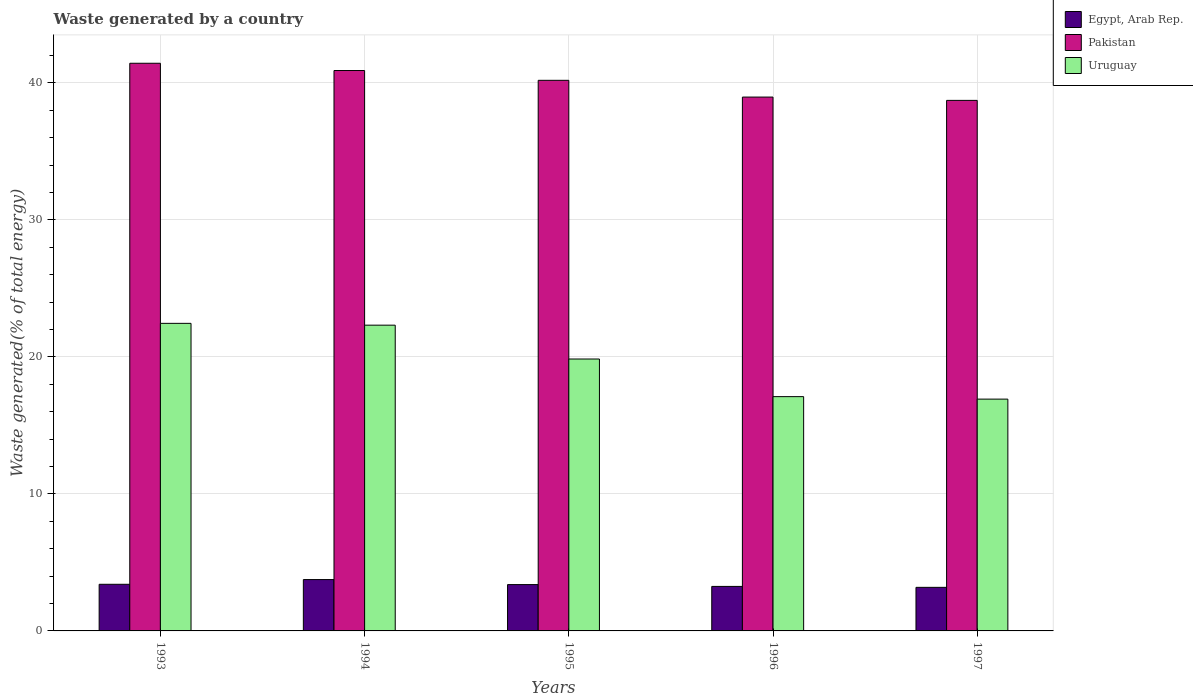Are the number of bars on each tick of the X-axis equal?
Provide a short and direct response. Yes. How many bars are there on the 3rd tick from the right?
Provide a short and direct response. 3. What is the label of the 5th group of bars from the left?
Keep it short and to the point. 1997. What is the total waste generated in Egypt, Arab Rep. in 1994?
Make the answer very short. 3.75. Across all years, what is the maximum total waste generated in Egypt, Arab Rep.?
Offer a terse response. 3.75. Across all years, what is the minimum total waste generated in Pakistan?
Offer a very short reply. 38.72. In which year was the total waste generated in Uruguay maximum?
Your answer should be very brief. 1993. In which year was the total waste generated in Pakistan minimum?
Offer a very short reply. 1997. What is the total total waste generated in Pakistan in the graph?
Offer a very short reply. 200.21. What is the difference between the total waste generated in Uruguay in 1994 and that in 1997?
Offer a terse response. 5.4. What is the difference between the total waste generated in Uruguay in 1993 and the total waste generated in Pakistan in 1994?
Offer a very short reply. -18.45. What is the average total waste generated in Egypt, Arab Rep. per year?
Keep it short and to the point. 3.39. In the year 1996, what is the difference between the total waste generated in Egypt, Arab Rep. and total waste generated in Uruguay?
Ensure brevity in your answer.  -13.85. In how many years, is the total waste generated in Uruguay greater than 36 %?
Make the answer very short. 0. What is the ratio of the total waste generated in Egypt, Arab Rep. in 1995 to that in 1997?
Your response must be concise. 1.06. What is the difference between the highest and the second highest total waste generated in Pakistan?
Make the answer very short. 0.53. What is the difference between the highest and the lowest total waste generated in Pakistan?
Your answer should be compact. 2.71. In how many years, is the total waste generated in Uruguay greater than the average total waste generated in Uruguay taken over all years?
Offer a terse response. 3. Is the sum of the total waste generated in Pakistan in 1995 and 1996 greater than the maximum total waste generated in Egypt, Arab Rep. across all years?
Ensure brevity in your answer.  Yes. What does the 3rd bar from the left in 1996 represents?
Your answer should be compact. Uruguay. What does the 1st bar from the right in 1996 represents?
Provide a short and direct response. Uruguay. Is it the case that in every year, the sum of the total waste generated in Egypt, Arab Rep. and total waste generated in Pakistan is greater than the total waste generated in Uruguay?
Provide a short and direct response. Yes. How many bars are there?
Offer a very short reply. 15. Are all the bars in the graph horizontal?
Provide a succinct answer. No. Are the values on the major ticks of Y-axis written in scientific E-notation?
Provide a short and direct response. No. Does the graph contain grids?
Offer a very short reply. Yes. Where does the legend appear in the graph?
Your answer should be compact. Top right. How many legend labels are there?
Offer a terse response. 3. How are the legend labels stacked?
Give a very brief answer. Vertical. What is the title of the graph?
Give a very brief answer. Waste generated by a country. Does "Mozambique" appear as one of the legend labels in the graph?
Keep it short and to the point. No. What is the label or title of the X-axis?
Your answer should be very brief. Years. What is the label or title of the Y-axis?
Give a very brief answer. Waste generated(% of total energy). What is the Waste generated(% of total energy) of Egypt, Arab Rep. in 1993?
Provide a succinct answer. 3.4. What is the Waste generated(% of total energy) in Pakistan in 1993?
Ensure brevity in your answer.  41.43. What is the Waste generated(% of total energy) in Uruguay in 1993?
Offer a very short reply. 22.45. What is the Waste generated(% of total energy) of Egypt, Arab Rep. in 1994?
Your answer should be very brief. 3.75. What is the Waste generated(% of total energy) in Pakistan in 1994?
Ensure brevity in your answer.  40.9. What is the Waste generated(% of total energy) of Uruguay in 1994?
Offer a terse response. 22.32. What is the Waste generated(% of total energy) in Egypt, Arab Rep. in 1995?
Your answer should be compact. 3.38. What is the Waste generated(% of total energy) in Pakistan in 1995?
Keep it short and to the point. 40.19. What is the Waste generated(% of total energy) of Uruguay in 1995?
Offer a very short reply. 19.85. What is the Waste generated(% of total energy) in Egypt, Arab Rep. in 1996?
Offer a terse response. 3.25. What is the Waste generated(% of total energy) of Pakistan in 1996?
Provide a succinct answer. 38.97. What is the Waste generated(% of total energy) in Uruguay in 1996?
Offer a terse response. 17.1. What is the Waste generated(% of total energy) of Egypt, Arab Rep. in 1997?
Make the answer very short. 3.18. What is the Waste generated(% of total energy) in Pakistan in 1997?
Provide a short and direct response. 38.72. What is the Waste generated(% of total energy) of Uruguay in 1997?
Ensure brevity in your answer.  16.92. Across all years, what is the maximum Waste generated(% of total energy) in Egypt, Arab Rep.?
Offer a terse response. 3.75. Across all years, what is the maximum Waste generated(% of total energy) of Pakistan?
Provide a short and direct response. 41.43. Across all years, what is the maximum Waste generated(% of total energy) of Uruguay?
Give a very brief answer. 22.45. Across all years, what is the minimum Waste generated(% of total energy) of Egypt, Arab Rep.?
Give a very brief answer. 3.18. Across all years, what is the minimum Waste generated(% of total energy) in Pakistan?
Offer a terse response. 38.72. Across all years, what is the minimum Waste generated(% of total energy) in Uruguay?
Offer a very short reply. 16.92. What is the total Waste generated(% of total energy) in Egypt, Arab Rep. in the graph?
Offer a terse response. 16.96. What is the total Waste generated(% of total energy) of Pakistan in the graph?
Your response must be concise. 200.21. What is the total Waste generated(% of total energy) in Uruguay in the graph?
Offer a terse response. 98.63. What is the difference between the Waste generated(% of total energy) in Egypt, Arab Rep. in 1993 and that in 1994?
Ensure brevity in your answer.  -0.34. What is the difference between the Waste generated(% of total energy) of Pakistan in 1993 and that in 1994?
Offer a very short reply. 0.53. What is the difference between the Waste generated(% of total energy) of Uruguay in 1993 and that in 1994?
Your answer should be compact. 0.13. What is the difference between the Waste generated(% of total energy) in Egypt, Arab Rep. in 1993 and that in 1995?
Provide a short and direct response. 0.02. What is the difference between the Waste generated(% of total energy) of Pakistan in 1993 and that in 1995?
Ensure brevity in your answer.  1.25. What is the difference between the Waste generated(% of total energy) of Uruguay in 1993 and that in 1995?
Provide a succinct answer. 2.6. What is the difference between the Waste generated(% of total energy) of Egypt, Arab Rep. in 1993 and that in 1996?
Your response must be concise. 0.15. What is the difference between the Waste generated(% of total energy) of Pakistan in 1993 and that in 1996?
Provide a short and direct response. 2.47. What is the difference between the Waste generated(% of total energy) in Uruguay in 1993 and that in 1996?
Ensure brevity in your answer.  5.35. What is the difference between the Waste generated(% of total energy) of Egypt, Arab Rep. in 1993 and that in 1997?
Keep it short and to the point. 0.22. What is the difference between the Waste generated(% of total energy) in Pakistan in 1993 and that in 1997?
Ensure brevity in your answer.  2.71. What is the difference between the Waste generated(% of total energy) of Uruguay in 1993 and that in 1997?
Make the answer very short. 5.53. What is the difference between the Waste generated(% of total energy) of Egypt, Arab Rep. in 1994 and that in 1995?
Your answer should be very brief. 0.37. What is the difference between the Waste generated(% of total energy) in Pakistan in 1994 and that in 1995?
Offer a very short reply. 0.71. What is the difference between the Waste generated(% of total energy) of Uruguay in 1994 and that in 1995?
Your response must be concise. 2.47. What is the difference between the Waste generated(% of total energy) of Egypt, Arab Rep. in 1994 and that in 1996?
Offer a terse response. 0.5. What is the difference between the Waste generated(% of total energy) of Pakistan in 1994 and that in 1996?
Provide a short and direct response. 1.94. What is the difference between the Waste generated(% of total energy) in Uruguay in 1994 and that in 1996?
Provide a succinct answer. 5.22. What is the difference between the Waste generated(% of total energy) in Egypt, Arab Rep. in 1994 and that in 1997?
Provide a short and direct response. 0.57. What is the difference between the Waste generated(% of total energy) of Pakistan in 1994 and that in 1997?
Provide a succinct answer. 2.18. What is the difference between the Waste generated(% of total energy) in Uruguay in 1994 and that in 1997?
Provide a succinct answer. 5.4. What is the difference between the Waste generated(% of total energy) in Egypt, Arab Rep. in 1995 and that in 1996?
Provide a succinct answer. 0.13. What is the difference between the Waste generated(% of total energy) of Pakistan in 1995 and that in 1996?
Make the answer very short. 1.22. What is the difference between the Waste generated(% of total energy) of Uruguay in 1995 and that in 1996?
Your response must be concise. 2.75. What is the difference between the Waste generated(% of total energy) of Egypt, Arab Rep. in 1995 and that in 1997?
Keep it short and to the point. 0.2. What is the difference between the Waste generated(% of total energy) of Pakistan in 1995 and that in 1997?
Keep it short and to the point. 1.47. What is the difference between the Waste generated(% of total energy) of Uruguay in 1995 and that in 1997?
Give a very brief answer. 2.93. What is the difference between the Waste generated(% of total energy) in Egypt, Arab Rep. in 1996 and that in 1997?
Make the answer very short. 0.07. What is the difference between the Waste generated(% of total energy) of Pakistan in 1996 and that in 1997?
Your response must be concise. 0.24. What is the difference between the Waste generated(% of total energy) of Uruguay in 1996 and that in 1997?
Provide a succinct answer. 0.18. What is the difference between the Waste generated(% of total energy) in Egypt, Arab Rep. in 1993 and the Waste generated(% of total energy) in Pakistan in 1994?
Provide a succinct answer. -37.5. What is the difference between the Waste generated(% of total energy) in Egypt, Arab Rep. in 1993 and the Waste generated(% of total energy) in Uruguay in 1994?
Keep it short and to the point. -18.91. What is the difference between the Waste generated(% of total energy) of Pakistan in 1993 and the Waste generated(% of total energy) of Uruguay in 1994?
Offer a terse response. 19.12. What is the difference between the Waste generated(% of total energy) of Egypt, Arab Rep. in 1993 and the Waste generated(% of total energy) of Pakistan in 1995?
Give a very brief answer. -36.78. What is the difference between the Waste generated(% of total energy) of Egypt, Arab Rep. in 1993 and the Waste generated(% of total energy) of Uruguay in 1995?
Your answer should be compact. -16.44. What is the difference between the Waste generated(% of total energy) of Pakistan in 1993 and the Waste generated(% of total energy) of Uruguay in 1995?
Offer a terse response. 21.59. What is the difference between the Waste generated(% of total energy) of Egypt, Arab Rep. in 1993 and the Waste generated(% of total energy) of Pakistan in 1996?
Give a very brief answer. -35.56. What is the difference between the Waste generated(% of total energy) of Egypt, Arab Rep. in 1993 and the Waste generated(% of total energy) of Uruguay in 1996?
Ensure brevity in your answer.  -13.7. What is the difference between the Waste generated(% of total energy) of Pakistan in 1993 and the Waste generated(% of total energy) of Uruguay in 1996?
Provide a succinct answer. 24.33. What is the difference between the Waste generated(% of total energy) in Egypt, Arab Rep. in 1993 and the Waste generated(% of total energy) in Pakistan in 1997?
Your answer should be compact. -35.32. What is the difference between the Waste generated(% of total energy) of Egypt, Arab Rep. in 1993 and the Waste generated(% of total energy) of Uruguay in 1997?
Offer a very short reply. -13.52. What is the difference between the Waste generated(% of total energy) of Pakistan in 1993 and the Waste generated(% of total energy) of Uruguay in 1997?
Offer a terse response. 24.51. What is the difference between the Waste generated(% of total energy) of Egypt, Arab Rep. in 1994 and the Waste generated(% of total energy) of Pakistan in 1995?
Offer a terse response. -36.44. What is the difference between the Waste generated(% of total energy) of Egypt, Arab Rep. in 1994 and the Waste generated(% of total energy) of Uruguay in 1995?
Provide a short and direct response. -16.1. What is the difference between the Waste generated(% of total energy) in Pakistan in 1994 and the Waste generated(% of total energy) in Uruguay in 1995?
Ensure brevity in your answer.  21.06. What is the difference between the Waste generated(% of total energy) of Egypt, Arab Rep. in 1994 and the Waste generated(% of total energy) of Pakistan in 1996?
Offer a very short reply. -35.22. What is the difference between the Waste generated(% of total energy) in Egypt, Arab Rep. in 1994 and the Waste generated(% of total energy) in Uruguay in 1996?
Your answer should be compact. -13.35. What is the difference between the Waste generated(% of total energy) in Pakistan in 1994 and the Waste generated(% of total energy) in Uruguay in 1996?
Provide a succinct answer. 23.8. What is the difference between the Waste generated(% of total energy) in Egypt, Arab Rep. in 1994 and the Waste generated(% of total energy) in Pakistan in 1997?
Your answer should be compact. -34.98. What is the difference between the Waste generated(% of total energy) in Egypt, Arab Rep. in 1994 and the Waste generated(% of total energy) in Uruguay in 1997?
Give a very brief answer. -13.17. What is the difference between the Waste generated(% of total energy) of Pakistan in 1994 and the Waste generated(% of total energy) of Uruguay in 1997?
Ensure brevity in your answer.  23.98. What is the difference between the Waste generated(% of total energy) of Egypt, Arab Rep. in 1995 and the Waste generated(% of total energy) of Pakistan in 1996?
Your answer should be compact. -35.58. What is the difference between the Waste generated(% of total energy) of Egypt, Arab Rep. in 1995 and the Waste generated(% of total energy) of Uruguay in 1996?
Provide a succinct answer. -13.72. What is the difference between the Waste generated(% of total energy) of Pakistan in 1995 and the Waste generated(% of total energy) of Uruguay in 1996?
Give a very brief answer. 23.09. What is the difference between the Waste generated(% of total energy) in Egypt, Arab Rep. in 1995 and the Waste generated(% of total energy) in Pakistan in 1997?
Your response must be concise. -35.34. What is the difference between the Waste generated(% of total energy) in Egypt, Arab Rep. in 1995 and the Waste generated(% of total energy) in Uruguay in 1997?
Provide a short and direct response. -13.54. What is the difference between the Waste generated(% of total energy) in Pakistan in 1995 and the Waste generated(% of total energy) in Uruguay in 1997?
Keep it short and to the point. 23.27. What is the difference between the Waste generated(% of total energy) of Egypt, Arab Rep. in 1996 and the Waste generated(% of total energy) of Pakistan in 1997?
Provide a short and direct response. -35.47. What is the difference between the Waste generated(% of total energy) in Egypt, Arab Rep. in 1996 and the Waste generated(% of total energy) in Uruguay in 1997?
Make the answer very short. -13.67. What is the difference between the Waste generated(% of total energy) of Pakistan in 1996 and the Waste generated(% of total energy) of Uruguay in 1997?
Provide a short and direct response. 22.05. What is the average Waste generated(% of total energy) of Egypt, Arab Rep. per year?
Your response must be concise. 3.39. What is the average Waste generated(% of total energy) of Pakistan per year?
Offer a terse response. 40.04. What is the average Waste generated(% of total energy) in Uruguay per year?
Your answer should be compact. 19.73. In the year 1993, what is the difference between the Waste generated(% of total energy) in Egypt, Arab Rep. and Waste generated(% of total energy) in Pakistan?
Give a very brief answer. -38.03. In the year 1993, what is the difference between the Waste generated(% of total energy) of Egypt, Arab Rep. and Waste generated(% of total energy) of Uruguay?
Offer a terse response. -19.05. In the year 1993, what is the difference between the Waste generated(% of total energy) in Pakistan and Waste generated(% of total energy) in Uruguay?
Your answer should be very brief. 18.98. In the year 1994, what is the difference between the Waste generated(% of total energy) of Egypt, Arab Rep. and Waste generated(% of total energy) of Pakistan?
Your answer should be compact. -37.16. In the year 1994, what is the difference between the Waste generated(% of total energy) of Egypt, Arab Rep. and Waste generated(% of total energy) of Uruguay?
Give a very brief answer. -18.57. In the year 1994, what is the difference between the Waste generated(% of total energy) in Pakistan and Waste generated(% of total energy) in Uruguay?
Keep it short and to the point. 18.59. In the year 1995, what is the difference between the Waste generated(% of total energy) of Egypt, Arab Rep. and Waste generated(% of total energy) of Pakistan?
Provide a succinct answer. -36.81. In the year 1995, what is the difference between the Waste generated(% of total energy) in Egypt, Arab Rep. and Waste generated(% of total energy) in Uruguay?
Offer a very short reply. -16.47. In the year 1995, what is the difference between the Waste generated(% of total energy) in Pakistan and Waste generated(% of total energy) in Uruguay?
Make the answer very short. 20.34. In the year 1996, what is the difference between the Waste generated(% of total energy) of Egypt, Arab Rep. and Waste generated(% of total energy) of Pakistan?
Keep it short and to the point. -35.72. In the year 1996, what is the difference between the Waste generated(% of total energy) in Egypt, Arab Rep. and Waste generated(% of total energy) in Uruguay?
Give a very brief answer. -13.85. In the year 1996, what is the difference between the Waste generated(% of total energy) in Pakistan and Waste generated(% of total energy) in Uruguay?
Offer a terse response. 21.86. In the year 1997, what is the difference between the Waste generated(% of total energy) of Egypt, Arab Rep. and Waste generated(% of total energy) of Pakistan?
Provide a succinct answer. -35.54. In the year 1997, what is the difference between the Waste generated(% of total energy) in Egypt, Arab Rep. and Waste generated(% of total energy) in Uruguay?
Keep it short and to the point. -13.74. In the year 1997, what is the difference between the Waste generated(% of total energy) in Pakistan and Waste generated(% of total energy) in Uruguay?
Your answer should be compact. 21.8. What is the ratio of the Waste generated(% of total energy) of Egypt, Arab Rep. in 1993 to that in 1994?
Keep it short and to the point. 0.91. What is the ratio of the Waste generated(% of total energy) of Uruguay in 1993 to that in 1994?
Offer a terse response. 1.01. What is the ratio of the Waste generated(% of total energy) in Egypt, Arab Rep. in 1993 to that in 1995?
Offer a very short reply. 1.01. What is the ratio of the Waste generated(% of total energy) in Pakistan in 1993 to that in 1995?
Keep it short and to the point. 1.03. What is the ratio of the Waste generated(% of total energy) in Uruguay in 1993 to that in 1995?
Provide a succinct answer. 1.13. What is the ratio of the Waste generated(% of total energy) in Egypt, Arab Rep. in 1993 to that in 1996?
Make the answer very short. 1.05. What is the ratio of the Waste generated(% of total energy) in Pakistan in 1993 to that in 1996?
Offer a very short reply. 1.06. What is the ratio of the Waste generated(% of total energy) of Uruguay in 1993 to that in 1996?
Give a very brief answer. 1.31. What is the ratio of the Waste generated(% of total energy) in Egypt, Arab Rep. in 1993 to that in 1997?
Offer a terse response. 1.07. What is the ratio of the Waste generated(% of total energy) of Pakistan in 1993 to that in 1997?
Offer a very short reply. 1.07. What is the ratio of the Waste generated(% of total energy) of Uruguay in 1993 to that in 1997?
Offer a very short reply. 1.33. What is the ratio of the Waste generated(% of total energy) in Egypt, Arab Rep. in 1994 to that in 1995?
Offer a terse response. 1.11. What is the ratio of the Waste generated(% of total energy) in Pakistan in 1994 to that in 1995?
Offer a very short reply. 1.02. What is the ratio of the Waste generated(% of total energy) in Uruguay in 1994 to that in 1995?
Give a very brief answer. 1.12. What is the ratio of the Waste generated(% of total energy) in Egypt, Arab Rep. in 1994 to that in 1996?
Give a very brief answer. 1.15. What is the ratio of the Waste generated(% of total energy) in Pakistan in 1994 to that in 1996?
Make the answer very short. 1.05. What is the ratio of the Waste generated(% of total energy) in Uruguay in 1994 to that in 1996?
Provide a succinct answer. 1.3. What is the ratio of the Waste generated(% of total energy) of Egypt, Arab Rep. in 1994 to that in 1997?
Ensure brevity in your answer.  1.18. What is the ratio of the Waste generated(% of total energy) in Pakistan in 1994 to that in 1997?
Ensure brevity in your answer.  1.06. What is the ratio of the Waste generated(% of total energy) of Uruguay in 1994 to that in 1997?
Your response must be concise. 1.32. What is the ratio of the Waste generated(% of total energy) of Egypt, Arab Rep. in 1995 to that in 1996?
Offer a very short reply. 1.04. What is the ratio of the Waste generated(% of total energy) in Pakistan in 1995 to that in 1996?
Keep it short and to the point. 1.03. What is the ratio of the Waste generated(% of total energy) of Uruguay in 1995 to that in 1996?
Your answer should be very brief. 1.16. What is the ratio of the Waste generated(% of total energy) of Egypt, Arab Rep. in 1995 to that in 1997?
Offer a very short reply. 1.06. What is the ratio of the Waste generated(% of total energy) in Pakistan in 1995 to that in 1997?
Provide a short and direct response. 1.04. What is the ratio of the Waste generated(% of total energy) in Uruguay in 1995 to that in 1997?
Your response must be concise. 1.17. What is the ratio of the Waste generated(% of total energy) in Egypt, Arab Rep. in 1996 to that in 1997?
Your answer should be very brief. 1.02. What is the ratio of the Waste generated(% of total energy) in Pakistan in 1996 to that in 1997?
Your answer should be very brief. 1.01. What is the ratio of the Waste generated(% of total energy) in Uruguay in 1996 to that in 1997?
Your answer should be very brief. 1.01. What is the difference between the highest and the second highest Waste generated(% of total energy) in Egypt, Arab Rep.?
Provide a short and direct response. 0.34. What is the difference between the highest and the second highest Waste generated(% of total energy) of Pakistan?
Ensure brevity in your answer.  0.53. What is the difference between the highest and the second highest Waste generated(% of total energy) of Uruguay?
Offer a very short reply. 0.13. What is the difference between the highest and the lowest Waste generated(% of total energy) of Egypt, Arab Rep.?
Offer a very short reply. 0.57. What is the difference between the highest and the lowest Waste generated(% of total energy) of Pakistan?
Provide a short and direct response. 2.71. What is the difference between the highest and the lowest Waste generated(% of total energy) of Uruguay?
Make the answer very short. 5.53. 